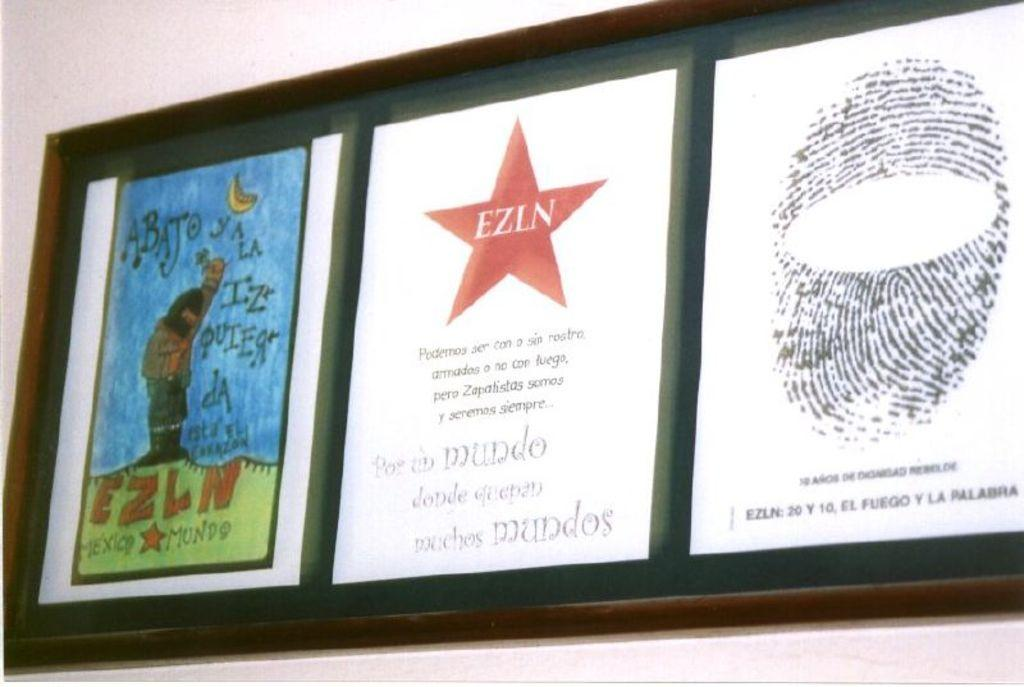<image>
Render a clear and concise summary of the photo. some papers with ezin in the middle of it 